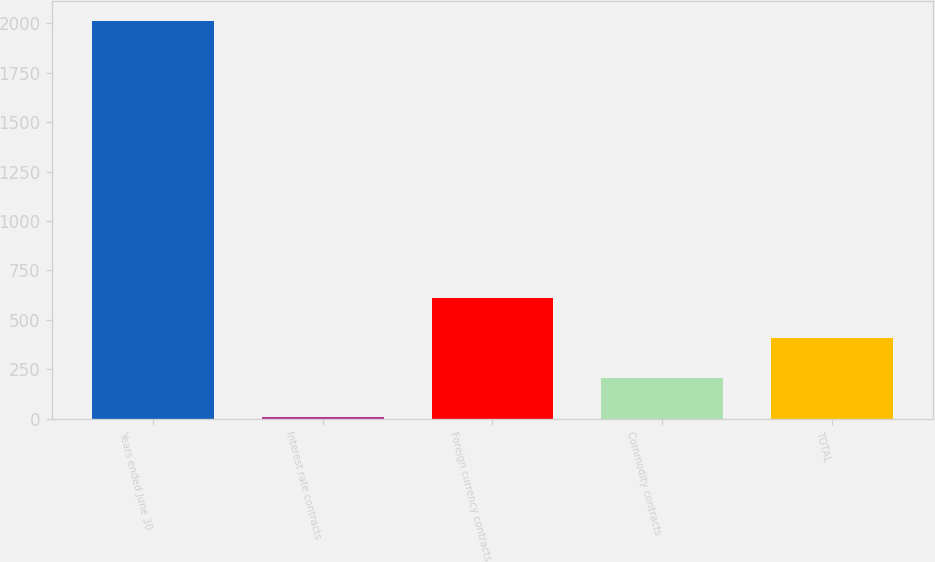Convert chart to OTSL. <chart><loc_0><loc_0><loc_500><loc_500><bar_chart><fcel>Years ended June 30<fcel>Interest rate contracts<fcel>Foreign currency contracts<fcel>Commodity contracts<fcel>TOTAL<nl><fcel>2011<fcel>7<fcel>608.2<fcel>207.4<fcel>407.8<nl></chart> 